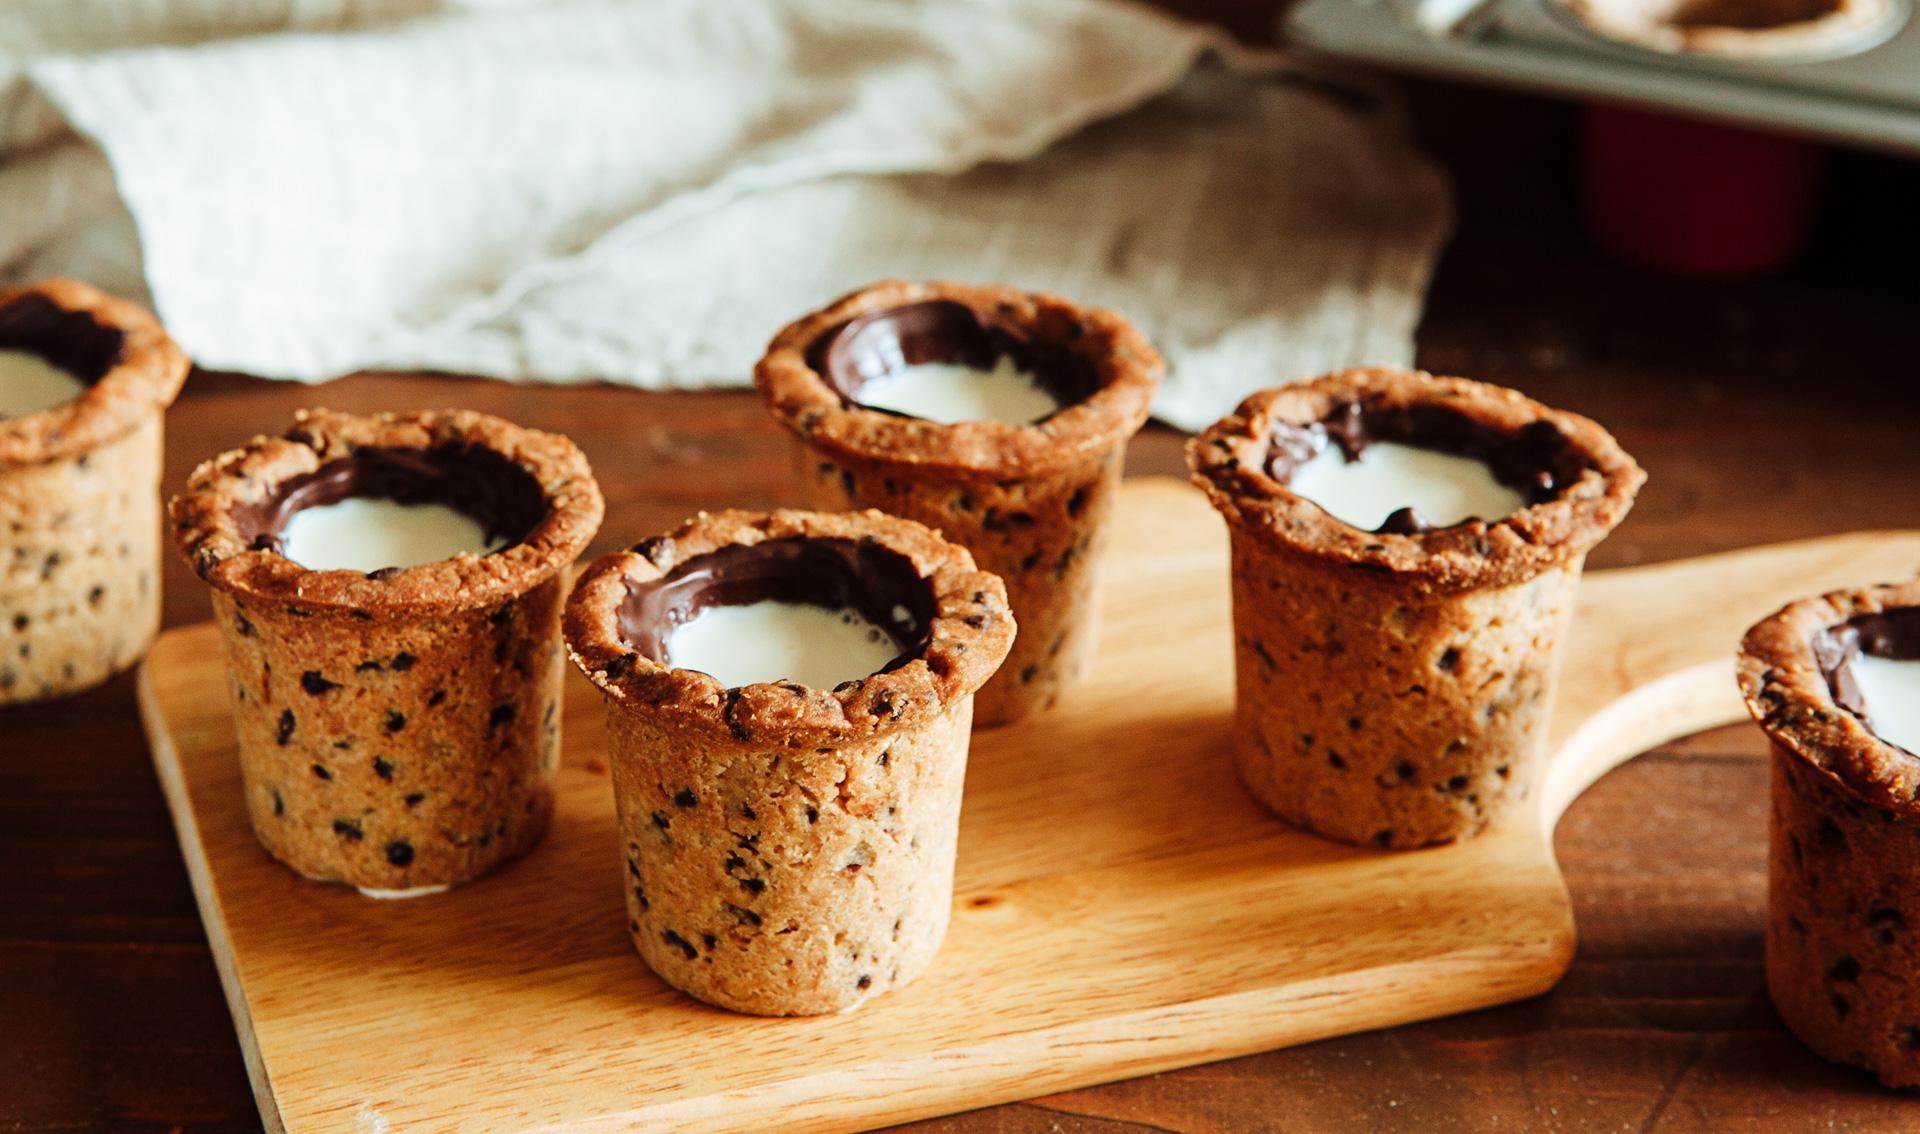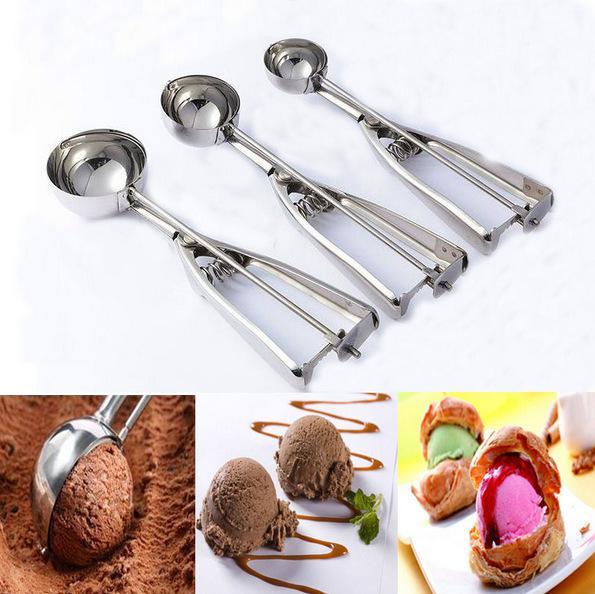The first image is the image on the left, the second image is the image on the right. Evaluate the accuracy of this statement regarding the images: "There is at least one human hand visible here.". Is it true? Answer yes or no. No. The first image is the image on the left, the second image is the image on the right. For the images displayed, is the sentence "Each image includes raw cookie dough, and at least one image includes raw cookie dough in a round bowl and a spoon with cookie dough on it." factually correct? Answer yes or no. No. 